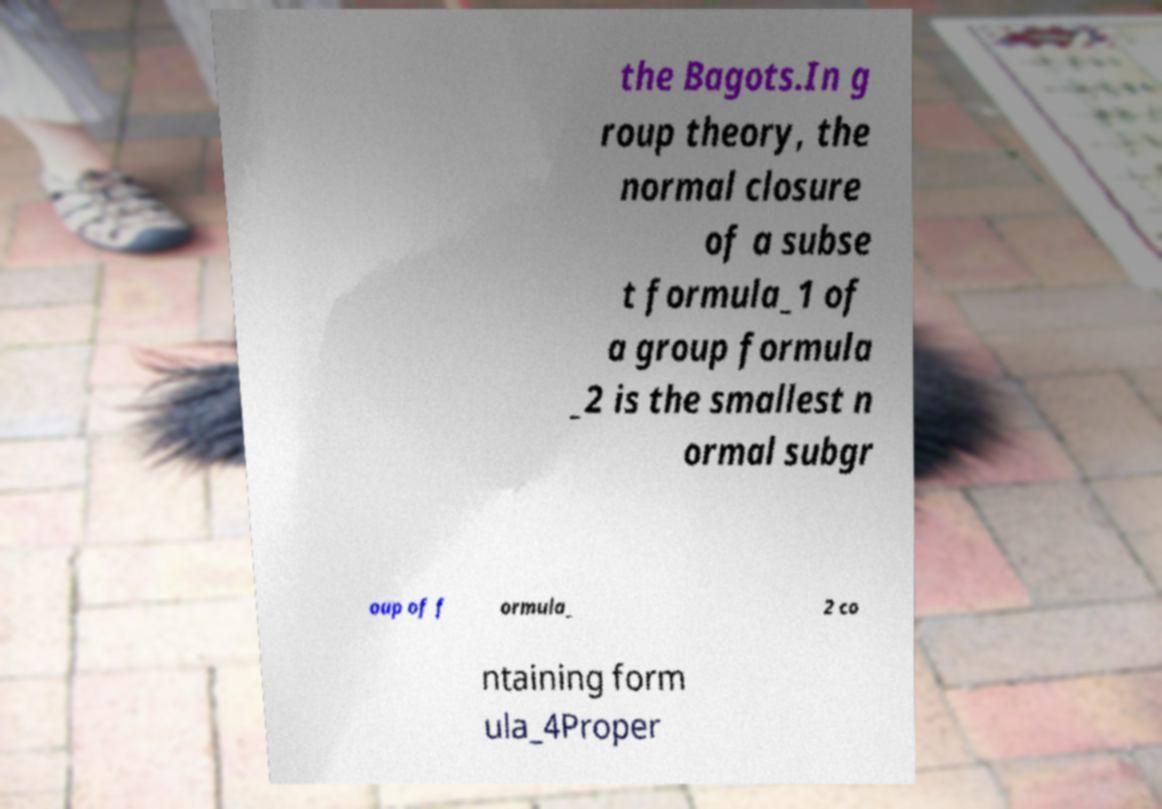Can you accurately transcribe the text from the provided image for me? the Bagots.In g roup theory, the normal closure of a subse t formula_1 of a group formula _2 is the smallest n ormal subgr oup of f ormula_ 2 co ntaining form ula_4Proper 